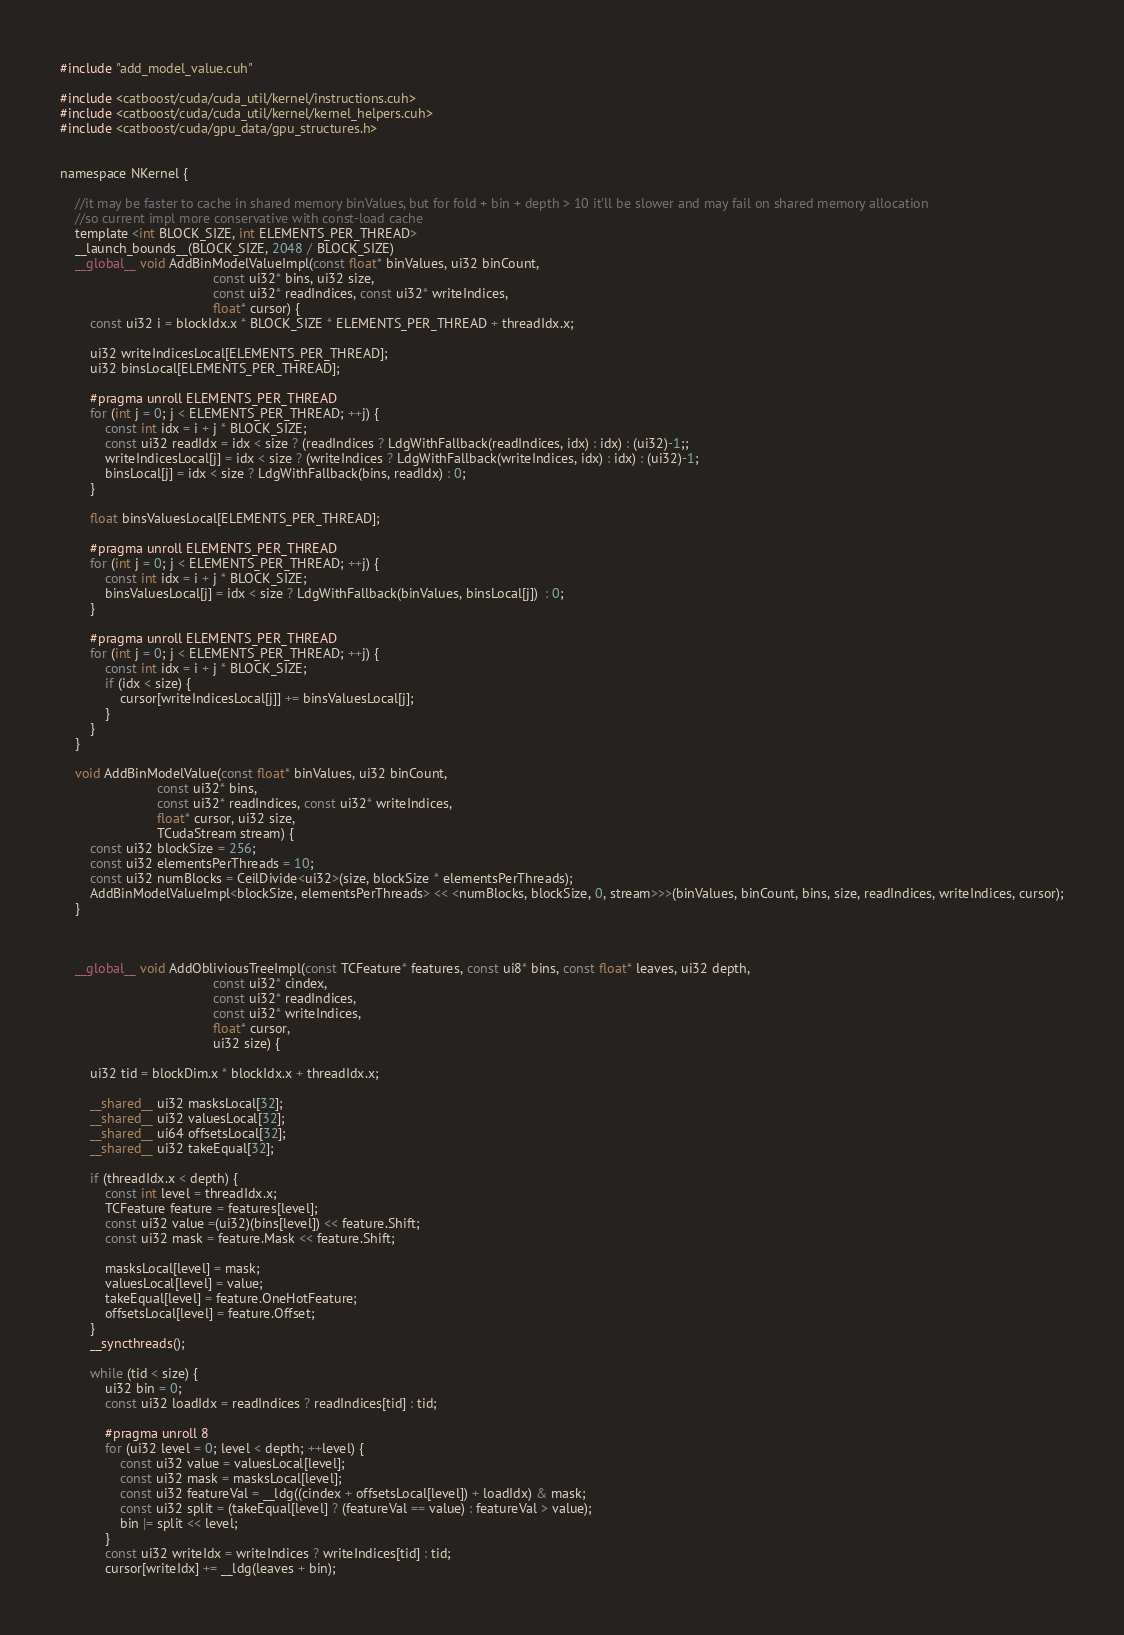<code> <loc_0><loc_0><loc_500><loc_500><_Cuda_>#include "add_model_value.cuh"

#include <catboost/cuda/cuda_util/kernel/instructions.cuh>
#include <catboost/cuda/cuda_util/kernel/kernel_helpers.cuh>
#include <catboost/cuda/gpu_data/gpu_structures.h>


namespace NKernel {

    //it may be faster to cache in shared memory binValues, but for fold + bin + depth > 10 it'll be slower and may fail on shared memory allocation
    //so current impl more conservative with const-load cache
    template <int BLOCK_SIZE, int ELEMENTS_PER_THREAD>
    __launch_bounds__(BLOCK_SIZE, 2048 / BLOCK_SIZE)
    __global__ void AddBinModelValueImpl(const float* binValues, ui32 binCount,
                                         const ui32* bins, ui32 size,
                                         const ui32* readIndices, const ui32* writeIndices,
                                         float* cursor) {
        const ui32 i = blockIdx.x * BLOCK_SIZE * ELEMENTS_PER_THREAD + threadIdx.x;

        ui32 writeIndicesLocal[ELEMENTS_PER_THREAD];
        ui32 binsLocal[ELEMENTS_PER_THREAD];

        #pragma unroll ELEMENTS_PER_THREAD
        for (int j = 0; j < ELEMENTS_PER_THREAD; ++j) {
            const int idx = i + j * BLOCK_SIZE;
            const ui32 readIdx = idx < size ? (readIndices ? LdgWithFallback(readIndices, idx) : idx) : (ui32)-1;;
            writeIndicesLocal[j] = idx < size ? (writeIndices ? LdgWithFallback(writeIndices, idx) : idx) : (ui32)-1;
            binsLocal[j] = idx < size ? LdgWithFallback(bins, readIdx) : 0;
        }

        float binsValuesLocal[ELEMENTS_PER_THREAD];

        #pragma unroll ELEMENTS_PER_THREAD
        for (int j = 0; j < ELEMENTS_PER_THREAD; ++j) {
            const int idx = i + j * BLOCK_SIZE;
            binsValuesLocal[j] = idx < size ? LdgWithFallback(binValues, binsLocal[j])  : 0;
        }

        #pragma unroll ELEMENTS_PER_THREAD
        for (int j = 0; j < ELEMENTS_PER_THREAD; ++j) {
            const int idx = i + j * BLOCK_SIZE;
            if (idx < size) {
                cursor[writeIndicesLocal[j]] += binsValuesLocal[j];
            }
        }
    }

    void AddBinModelValue(const float* binValues, ui32 binCount,
                          const ui32* bins,
                          const ui32* readIndices, const ui32* writeIndices,
                          float* cursor, ui32 size,
                          TCudaStream stream) {
        const ui32 blockSize = 256;
        const ui32 elementsPerThreads = 10;
        const ui32 numBlocks = CeilDivide<ui32>(size, blockSize * elementsPerThreads);
        AddBinModelValueImpl<blockSize, elementsPerThreads> << <numBlocks, blockSize, 0, stream>>>(binValues, binCount, bins, size, readIndices, writeIndices, cursor);
    }



    __global__ void AddObliviousTreeImpl(const TCFeature* features, const ui8* bins, const float* leaves, ui32 depth,
                                         const ui32* cindex,
                                         const ui32* readIndices,
                                         const ui32* writeIndices,
                                         float* cursor,
                                         ui32 size) {

        ui32 tid = blockDim.x * blockIdx.x + threadIdx.x;

        __shared__ ui32 masksLocal[32];
        __shared__ ui32 valuesLocal[32];
        __shared__ ui64 offsetsLocal[32];
        __shared__ ui32 takeEqual[32];

        if (threadIdx.x < depth) {
            const int level = threadIdx.x;
            TCFeature feature = features[level];
            const ui32 value =(ui32)(bins[level]) << feature.Shift;
            const ui32 mask = feature.Mask << feature.Shift;

            masksLocal[level] = mask;
            valuesLocal[level] = value;
            takeEqual[level] = feature.OneHotFeature;
            offsetsLocal[level] = feature.Offset;
        }
        __syncthreads();

        while (tid < size) {
            ui32 bin = 0;
            const ui32 loadIdx = readIndices ? readIndices[tid] : tid;

            #pragma unroll 8
            for (ui32 level = 0; level < depth; ++level) {
                const ui32 value = valuesLocal[level];
                const ui32 mask = masksLocal[level];
                const ui32 featureVal = __ldg((cindex + offsetsLocal[level]) + loadIdx) & mask;
                const ui32 split = (takeEqual[level] ? (featureVal == value) : featureVal > value);
                bin |= split << level;
            }
            const ui32 writeIdx = writeIndices ? writeIndices[tid] : tid;
            cursor[writeIdx] += __ldg(leaves + bin);</code> 